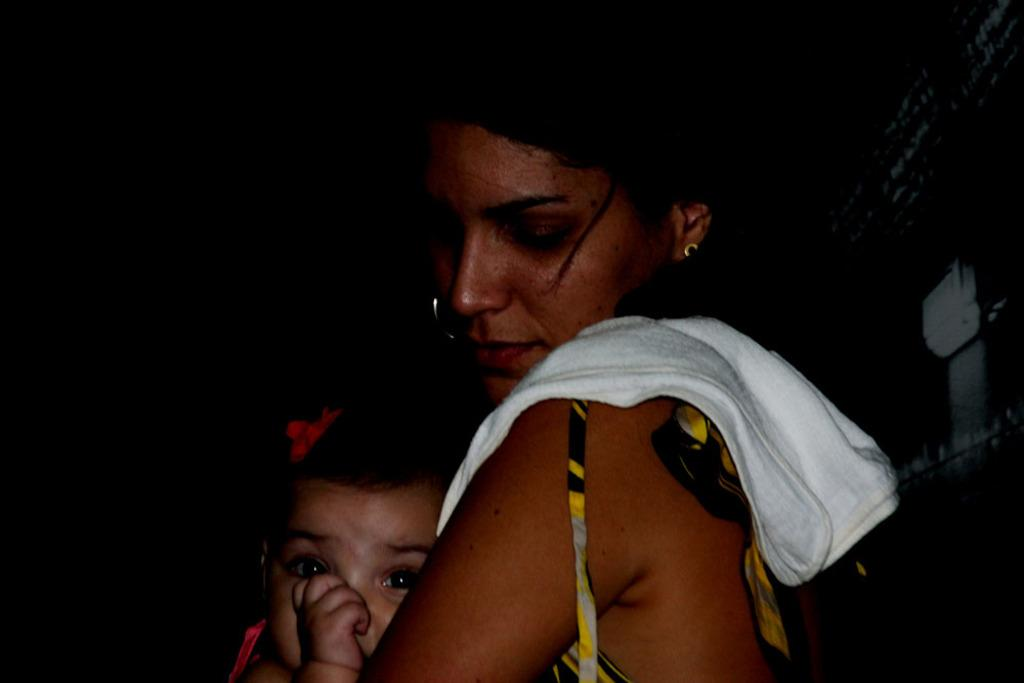Who is the main subject in the image? There is a woman in the image. What is the woman doing in the image? The woman is holding a child. What can be observed about the background of the image? The background of the image is dark. What type of quarter is being used to jump over the kettle in the image? There is no quarter or kettle present in the image. 